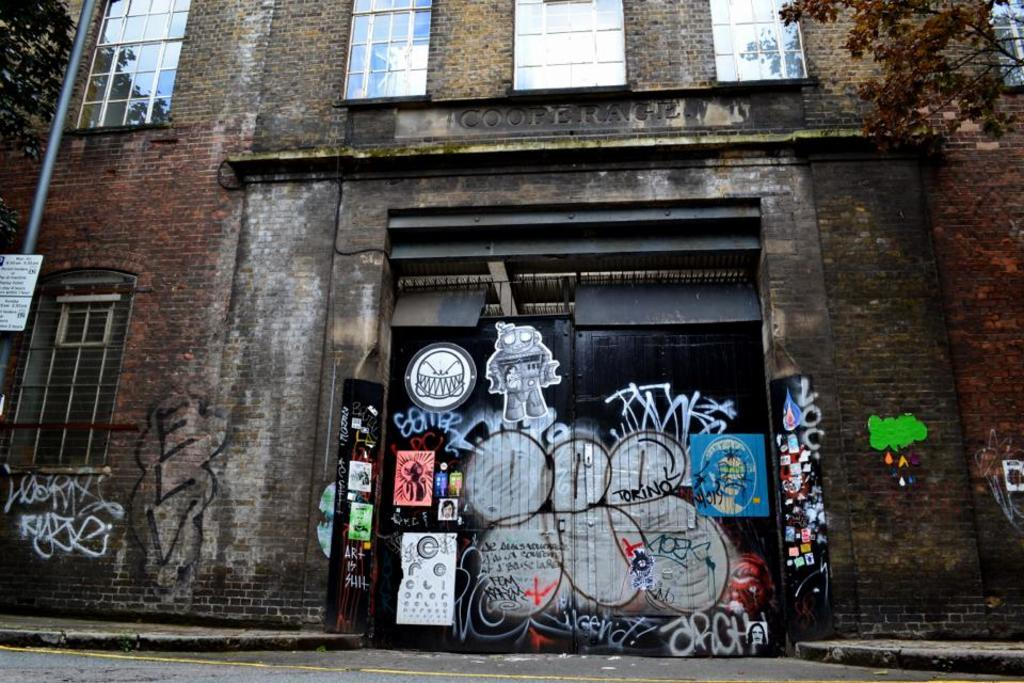What type of surface can be seen in the image? There is ground visible in the image. What material is the building made of? The building in the image is made of bricks. What architectural features are present in the building? There are windows in the building. What type of vegetation is present in the image? There are trees in the image. What is the color and size of the gate in the image? There is a huge black-colored gate in the image. Is there any artwork on the gate? Yes, there is a painting on the gate. Can you see any chickens walking in space near the gate in the image? No, there are no chickens or space elements present in the image. The image features a building, trees, a gate, and a painting on the gate. 